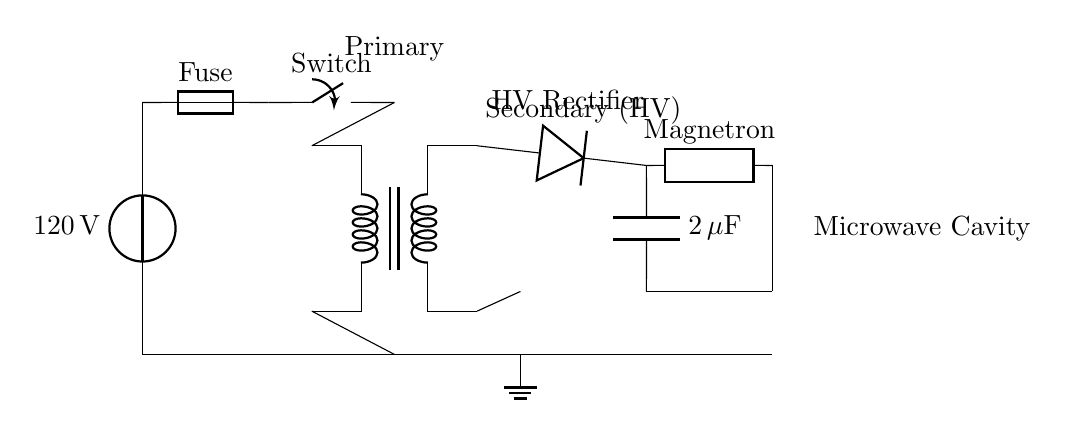What is the voltage of the power source? The voltage source in the circuit is labeled as 120 volts, which indicates the potential difference supplied to the system.
Answer: 120 volts What component is used to protect the circuit? The fuse is present in the circuit, which is designed to protect the circuit from excessive current by breaking the connection if the current exceeds a certain level.
Answer: Fuse What is the function of the transformer in this circuit? The transformer is responsible for stepping up or stepping down the voltage in the circuit, converting the low voltage input from the power source to a higher voltage output required for the microwave oven operation.
Answer: Voltage conversion What type of rectification is used at the high-voltage side? A diode is used in the circuit to perform high-voltage rectification, which converts alternating current (AC) into direct current (DC) necessary for operating the microwave oven.
Answer: Diode How many microfarads is the capacitor in the circuit? The capacitor is labeled as 2 microfarads, indicating its capacitance value, which is an important specification for energy storage in this circuit.
Answer: 2 microfarads What connects the high-voltage side to the magnetron? A wire connects the high-voltage side (output from the diode) directly to the magnetron, facilitating the power transfer required for microwave generation.
Answer: Wire What happens when the switch is open? When the switch is open, it interrupts the circuit connection, preventing current from flowing, which means the microwave oven will not operate.
Answer: Current stops 